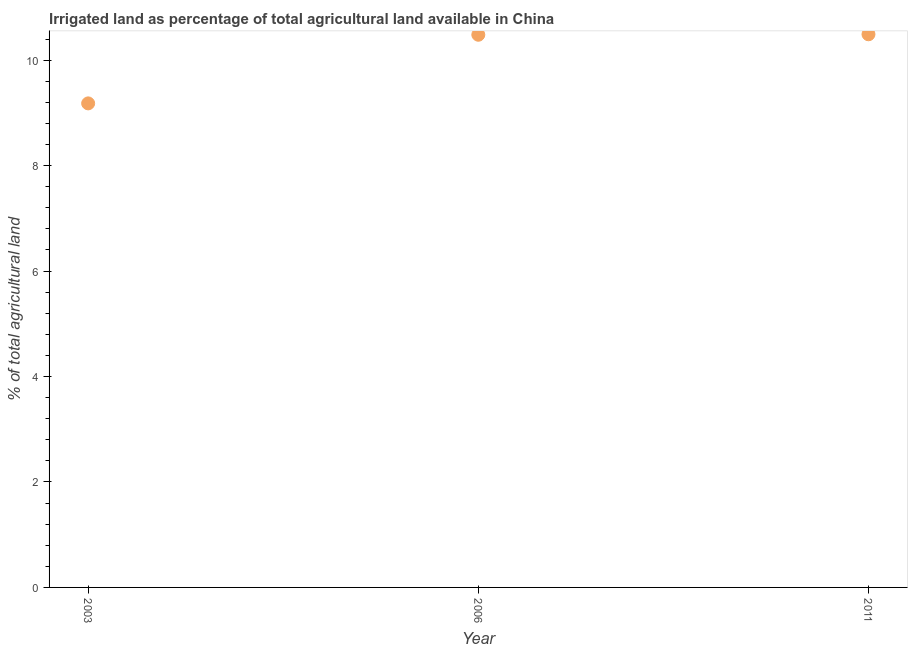What is the percentage of agricultural irrigated land in 2003?
Make the answer very short. 9.18. Across all years, what is the maximum percentage of agricultural irrigated land?
Your response must be concise. 10.49. Across all years, what is the minimum percentage of agricultural irrigated land?
Your response must be concise. 9.18. In which year was the percentage of agricultural irrigated land maximum?
Make the answer very short. 2011. In which year was the percentage of agricultural irrigated land minimum?
Make the answer very short. 2003. What is the sum of the percentage of agricultural irrigated land?
Your response must be concise. 30.15. What is the difference between the percentage of agricultural irrigated land in 2003 and 2006?
Your answer should be very brief. -1.3. What is the average percentage of agricultural irrigated land per year?
Your response must be concise. 10.05. What is the median percentage of agricultural irrigated land?
Offer a very short reply. 10.48. In how many years, is the percentage of agricultural irrigated land greater than 7.2 %?
Offer a terse response. 3. Do a majority of the years between 2006 and 2011 (inclusive) have percentage of agricultural irrigated land greater than 5.6 %?
Offer a terse response. Yes. What is the ratio of the percentage of agricultural irrigated land in 2003 to that in 2006?
Your answer should be very brief. 0.88. What is the difference between the highest and the second highest percentage of agricultural irrigated land?
Provide a succinct answer. 0.01. Is the sum of the percentage of agricultural irrigated land in 2003 and 2006 greater than the maximum percentage of agricultural irrigated land across all years?
Give a very brief answer. Yes. What is the difference between the highest and the lowest percentage of agricultural irrigated land?
Keep it short and to the point. 1.31. In how many years, is the percentage of agricultural irrigated land greater than the average percentage of agricultural irrigated land taken over all years?
Offer a terse response. 2. What is the difference between two consecutive major ticks on the Y-axis?
Provide a short and direct response. 2. Does the graph contain any zero values?
Your response must be concise. No. What is the title of the graph?
Offer a terse response. Irrigated land as percentage of total agricultural land available in China. What is the label or title of the Y-axis?
Ensure brevity in your answer.  % of total agricultural land. What is the % of total agricultural land in 2003?
Make the answer very short. 9.18. What is the % of total agricultural land in 2006?
Your answer should be very brief. 10.48. What is the % of total agricultural land in 2011?
Ensure brevity in your answer.  10.49. What is the difference between the % of total agricultural land in 2003 and 2006?
Provide a succinct answer. -1.3. What is the difference between the % of total agricultural land in 2003 and 2011?
Offer a very short reply. -1.31. What is the difference between the % of total agricultural land in 2006 and 2011?
Your response must be concise. -0.01. What is the ratio of the % of total agricultural land in 2003 to that in 2006?
Your response must be concise. 0.88. 